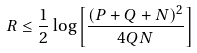<formula> <loc_0><loc_0><loc_500><loc_500>R \leq \frac { 1 } { 2 } \log \left [ \frac { ( P + Q + N ) ^ { 2 } } { 4 Q N } \right ]</formula> 